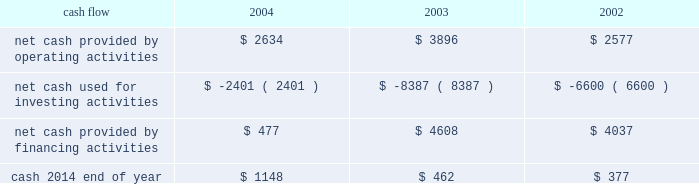On october 21 , 2004 , the hartford declared a dividend on its common stock of $ 0.29 per share payable on january 3 , 2005 to shareholders of record as of december 1 , 2004 .
The hartford declared $ 331 and paid $ 325 in dividends to shareholders in 2004 , declared $ 300 and paid $ 291 in dividends to shareholders in 2003 , declared $ 262 and paid $ 257 in 2002 .
Aoci - aoci increased by $ 179 as of december 31 , 2004 compared with december 31 , 2003 .
The increase in aoci is primarily the result of life 2019s adoption of sop 03-1 , which resulted in a $ 292 cumulative effect for unrealized gains on securities in the first quarter of 2004 related to the reclassification of investments from separate account assets to general account assets , partially offset by net unrealized losses on cash-flow hedging instruments .
The funded status of the company 2019s pension and postretirement plans is dependent upon many factors , including returns on invested assets and the level of market interest rates .
Declines in the value of securities traded in equity markets coupled with declines in long- term interest rates have had a negative impact on the funded status of the plans .
As a result , the company recorded a minimum pension liability as of december 31 , 2004 , and 2003 , which resulted in an after-tax reduction of stockholders 2019 equity of $ 480 and $ 375 respectively .
This minimum pension liability did not affect the company 2019s results of operations .
For additional information on stockholders 2019 equity and aoci see notes 15 and 16 , respectively , of notes to consolidated financial statements .
Cash flow 2004 2003 2002 .
2004 compared to 2003 2014 cash from operating activities primarily reflects premium cash flows in excess of claim payments .
The decrease in cash provided by operating activities was due primarily to the $ 1.15 billion settlement of the macarthur litigation in 2004 .
Cash provided by financing activities decreased primarily due to lower proceeds from investment and universal life-type contracts as a result of the adoption of sop 03-1 , decreased capital raising activities , repayment of commercial paper and early retirement of junior subordinated debentures in 2004 .
The decrease in cash from financing activities and operating cash flows invested long-term accounted for the majority of the change in cash used for investing activities .
2003 compared to 2002 2014 the increase in cash provided by operating activities was primarily the result of strong premium cash flows .
Financing activities increased primarily due to capital raising activities related to the 2003 asbestos reserve addition and decreased due to repayments on long-term debt and lower proceeds from investment and universal life-type contracts .
The increase in cash from financing activities accounted for the majority of the change in cash used for investing activities .
Operating cash flows in each of the last three years have been adequate to meet liquidity requirements .
Equity markets for a discussion of the potential impact of the equity markets on capital and liquidity , see the capital markets risk management section under 201cmarket risk 201d .
Ratings ratings are an important factor in establishing the competitive position in the insurance and financial services marketplace .
There can be no assurance that the company's ratings will continue for any given period of time or that they will not be changed .
In the event the company's ratings are downgraded , the level of revenues or the persistency of the company's business may be adversely impacted .
On august 4 , 2004 , moody 2019s affirmed the company 2019s and hartford life , inc . 2019s a3 senior debt ratings as well as the aa3 insurance financial strength ratings of both its property-casualty and life insurance operating subsidiaries .
In addition , moody 2019s changed the outlook for all of these ratings from negative to stable .
Since the announcement of the suit filed by the new york attorney general 2019s office against marsh & mclennan companies , inc. , and marsh , inc .
On october 14 , 2004 , the major independent ratings agencies have indicated that they continue to monitor developments relating to the suit .
On october 22 , 2004 , standard & poor 2019s revised its outlook on the u.s .
Property/casualty commercial lines sector to negative from stable .
On november 23 , 2004 , standard & poor 2019s revised its outlook on the financial strength and credit ratings of the property-casualty insurance subsidiaries to negative from stable .
The outlook on the life insurance subsidiaries and corporate debt was unaffected. .
What is the net chance in cash in 2004? 
Computations: (1148 - 462)
Answer: 686.0. 